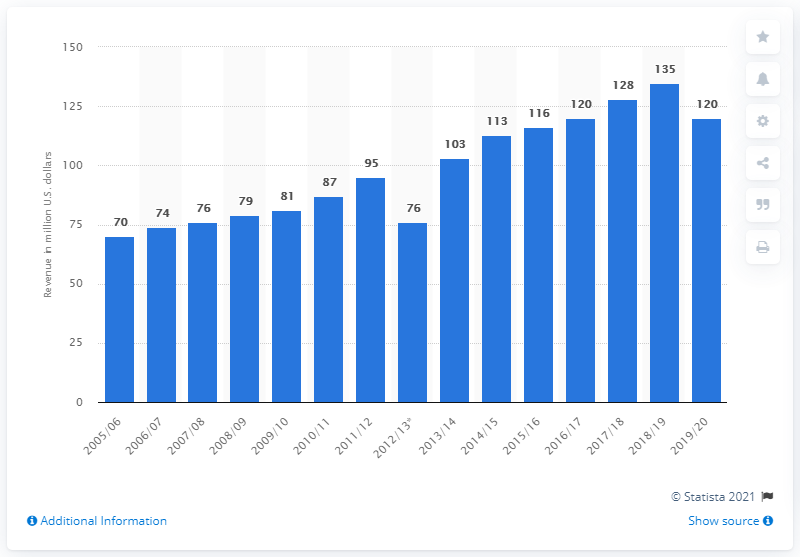Identify some key points in this picture. The Buffalo Sabres made a total of 120 million dollars in revenue during the 2019/2020 season. 